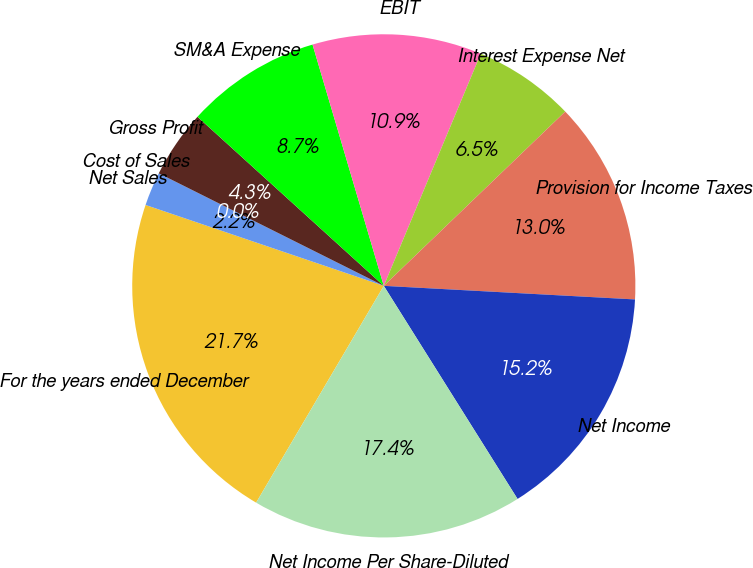Convert chart. <chart><loc_0><loc_0><loc_500><loc_500><pie_chart><fcel>For the years ended December<fcel>Net Sales<fcel>Cost of Sales<fcel>Gross Profit<fcel>SM&A Expense<fcel>EBIT<fcel>Interest Expense Net<fcel>Provision for Income Taxes<fcel>Net Income<fcel>Net Income Per Share-Diluted<nl><fcel>21.74%<fcel>2.17%<fcel>0.0%<fcel>4.35%<fcel>8.7%<fcel>10.87%<fcel>6.52%<fcel>13.04%<fcel>15.22%<fcel>17.39%<nl></chart> 